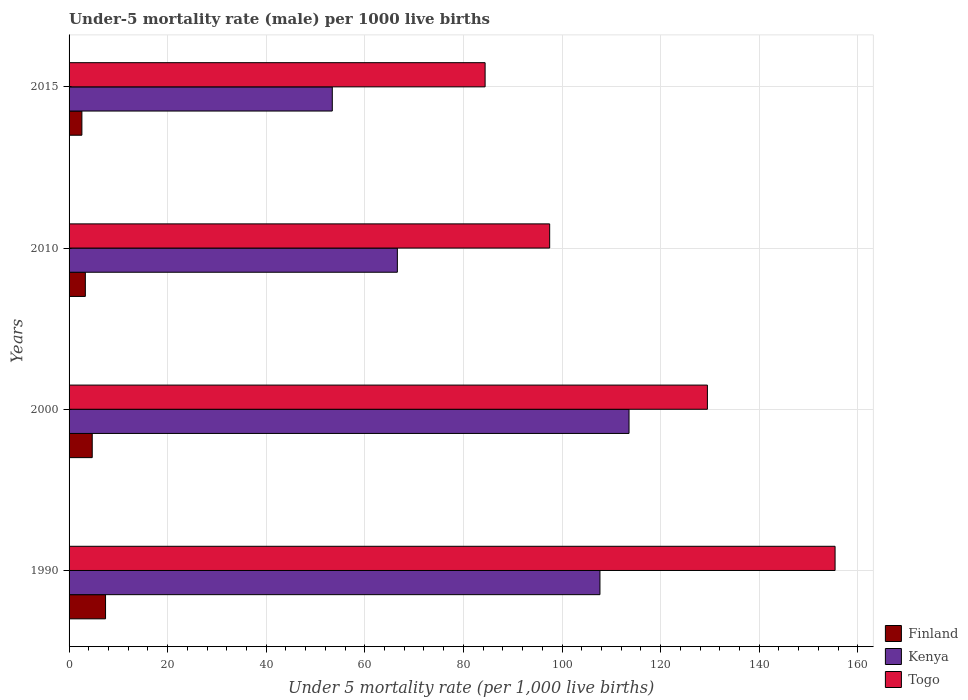How many groups of bars are there?
Ensure brevity in your answer.  4. Are the number of bars per tick equal to the number of legend labels?
Make the answer very short. Yes. Are the number of bars on each tick of the Y-axis equal?
Your answer should be compact. Yes. How many bars are there on the 2nd tick from the bottom?
Provide a succinct answer. 3. Across all years, what is the minimum under-five mortality rate in Finland?
Your answer should be very brief. 2.6. In which year was the under-five mortality rate in Kenya maximum?
Provide a short and direct response. 2000. In which year was the under-five mortality rate in Kenya minimum?
Offer a terse response. 2015. What is the total under-five mortality rate in Togo in the graph?
Your answer should be compact. 466.8. What is the difference between the under-five mortality rate in Kenya in 1990 and that in 2000?
Offer a very short reply. -5.9. What is the difference between the under-five mortality rate in Kenya in 2000 and the under-five mortality rate in Togo in 2015?
Ensure brevity in your answer.  29.2. What is the average under-five mortality rate in Togo per year?
Ensure brevity in your answer.  116.7. In the year 1990, what is the difference between the under-five mortality rate in Finland and under-five mortality rate in Togo?
Make the answer very short. -148. What is the ratio of the under-five mortality rate in Kenya in 1990 to that in 2010?
Offer a very short reply. 1.62. Is the under-five mortality rate in Finland in 1990 less than that in 2000?
Provide a short and direct response. No. What is the difference between the highest and the second highest under-five mortality rate in Kenya?
Offer a terse response. 5.9. What does the 3rd bar from the top in 1990 represents?
Your answer should be compact. Finland. What does the 3rd bar from the bottom in 2010 represents?
Give a very brief answer. Togo. How many bars are there?
Your answer should be compact. 12. Are all the bars in the graph horizontal?
Make the answer very short. Yes. What is the difference between two consecutive major ticks on the X-axis?
Your answer should be compact. 20. Does the graph contain any zero values?
Make the answer very short. No. Does the graph contain grids?
Give a very brief answer. Yes. How many legend labels are there?
Provide a succinct answer. 3. What is the title of the graph?
Provide a short and direct response. Under-5 mortality rate (male) per 1000 live births. What is the label or title of the X-axis?
Your answer should be compact. Under 5 mortality rate (per 1,0 live births). What is the Under 5 mortality rate (per 1,000 live births) in Kenya in 1990?
Give a very brief answer. 107.7. What is the Under 5 mortality rate (per 1,000 live births) in Togo in 1990?
Your response must be concise. 155.4. What is the Under 5 mortality rate (per 1,000 live births) in Finland in 2000?
Your response must be concise. 4.7. What is the Under 5 mortality rate (per 1,000 live births) in Kenya in 2000?
Provide a short and direct response. 113.6. What is the Under 5 mortality rate (per 1,000 live births) in Togo in 2000?
Ensure brevity in your answer.  129.5. What is the Under 5 mortality rate (per 1,000 live births) in Kenya in 2010?
Provide a succinct answer. 66.6. What is the Under 5 mortality rate (per 1,000 live births) in Togo in 2010?
Offer a very short reply. 97.5. What is the Under 5 mortality rate (per 1,000 live births) of Finland in 2015?
Your answer should be compact. 2.6. What is the Under 5 mortality rate (per 1,000 live births) of Kenya in 2015?
Ensure brevity in your answer.  53.4. What is the Under 5 mortality rate (per 1,000 live births) in Togo in 2015?
Your answer should be compact. 84.4. Across all years, what is the maximum Under 5 mortality rate (per 1,000 live births) of Kenya?
Your answer should be very brief. 113.6. Across all years, what is the maximum Under 5 mortality rate (per 1,000 live births) in Togo?
Provide a short and direct response. 155.4. Across all years, what is the minimum Under 5 mortality rate (per 1,000 live births) of Kenya?
Your answer should be very brief. 53.4. Across all years, what is the minimum Under 5 mortality rate (per 1,000 live births) in Togo?
Your response must be concise. 84.4. What is the total Under 5 mortality rate (per 1,000 live births) of Finland in the graph?
Offer a very short reply. 18. What is the total Under 5 mortality rate (per 1,000 live births) in Kenya in the graph?
Provide a succinct answer. 341.3. What is the total Under 5 mortality rate (per 1,000 live births) in Togo in the graph?
Keep it short and to the point. 466.8. What is the difference between the Under 5 mortality rate (per 1,000 live births) in Finland in 1990 and that in 2000?
Make the answer very short. 2.7. What is the difference between the Under 5 mortality rate (per 1,000 live births) in Togo in 1990 and that in 2000?
Provide a succinct answer. 25.9. What is the difference between the Under 5 mortality rate (per 1,000 live births) of Kenya in 1990 and that in 2010?
Provide a short and direct response. 41.1. What is the difference between the Under 5 mortality rate (per 1,000 live births) in Togo in 1990 and that in 2010?
Give a very brief answer. 57.9. What is the difference between the Under 5 mortality rate (per 1,000 live births) of Kenya in 1990 and that in 2015?
Ensure brevity in your answer.  54.3. What is the difference between the Under 5 mortality rate (per 1,000 live births) in Togo in 1990 and that in 2015?
Provide a short and direct response. 71. What is the difference between the Under 5 mortality rate (per 1,000 live births) of Finland in 2000 and that in 2010?
Provide a short and direct response. 1.4. What is the difference between the Under 5 mortality rate (per 1,000 live births) of Kenya in 2000 and that in 2010?
Keep it short and to the point. 47. What is the difference between the Under 5 mortality rate (per 1,000 live births) of Finland in 2000 and that in 2015?
Offer a very short reply. 2.1. What is the difference between the Under 5 mortality rate (per 1,000 live births) of Kenya in 2000 and that in 2015?
Give a very brief answer. 60.2. What is the difference between the Under 5 mortality rate (per 1,000 live births) in Togo in 2000 and that in 2015?
Keep it short and to the point. 45.1. What is the difference between the Under 5 mortality rate (per 1,000 live births) in Finland in 2010 and that in 2015?
Offer a very short reply. 0.7. What is the difference between the Under 5 mortality rate (per 1,000 live births) in Kenya in 2010 and that in 2015?
Ensure brevity in your answer.  13.2. What is the difference between the Under 5 mortality rate (per 1,000 live births) in Togo in 2010 and that in 2015?
Your answer should be compact. 13.1. What is the difference between the Under 5 mortality rate (per 1,000 live births) of Finland in 1990 and the Under 5 mortality rate (per 1,000 live births) of Kenya in 2000?
Make the answer very short. -106.2. What is the difference between the Under 5 mortality rate (per 1,000 live births) in Finland in 1990 and the Under 5 mortality rate (per 1,000 live births) in Togo in 2000?
Your response must be concise. -122.1. What is the difference between the Under 5 mortality rate (per 1,000 live births) in Kenya in 1990 and the Under 5 mortality rate (per 1,000 live births) in Togo in 2000?
Your answer should be very brief. -21.8. What is the difference between the Under 5 mortality rate (per 1,000 live births) in Finland in 1990 and the Under 5 mortality rate (per 1,000 live births) in Kenya in 2010?
Your answer should be compact. -59.2. What is the difference between the Under 5 mortality rate (per 1,000 live births) of Finland in 1990 and the Under 5 mortality rate (per 1,000 live births) of Togo in 2010?
Keep it short and to the point. -90.1. What is the difference between the Under 5 mortality rate (per 1,000 live births) in Finland in 1990 and the Under 5 mortality rate (per 1,000 live births) in Kenya in 2015?
Ensure brevity in your answer.  -46. What is the difference between the Under 5 mortality rate (per 1,000 live births) of Finland in 1990 and the Under 5 mortality rate (per 1,000 live births) of Togo in 2015?
Provide a short and direct response. -77. What is the difference between the Under 5 mortality rate (per 1,000 live births) in Kenya in 1990 and the Under 5 mortality rate (per 1,000 live births) in Togo in 2015?
Keep it short and to the point. 23.3. What is the difference between the Under 5 mortality rate (per 1,000 live births) of Finland in 2000 and the Under 5 mortality rate (per 1,000 live births) of Kenya in 2010?
Your response must be concise. -61.9. What is the difference between the Under 5 mortality rate (per 1,000 live births) in Finland in 2000 and the Under 5 mortality rate (per 1,000 live births) in Togo in 2010?
Your answer should be compact. -92.8. What is the difference between the Under 5 mortality rate (per 1,000 live births) of Kenya in 2000 and the Under 5 mortality rate (per 1,000 live births) of Togo in 2010?
Give a very brief answer. 16.1. What is the difference between the Under 5 mortality rate (per 1,000 live births) in Finland in 2000 and the Under 5 mortality rate (per 1,000 live births) in Kenya in 2015?
Give a very brief answer. -48.7. What is the difference between the Under 5 mortality rate (per 1,000 live births) in Finland in 2000 and the Under 5 mortality rate (per 1,000 live births) in Togo in 2015?
Give a very brief answer. -79.7. What is the difference between the Under 5 mortality rate (per 1,000 live births) of Kenya in 2000 and the Under 5 mortality rate (per 1,000 live births) of Togo in 2015?
Your answer should be compact. 29.2. What is the difference between the Under 5 mortality rate (per 1,000 live births) of Finland in 2010 and the Under 5 mortality rate (per 1,000 live births) of Kenya in 2015?
Give a very brief answer. -50.1. What is the difference between the Under 5 mortality rate (per 1,000 live births) in Finland in 2010 and the Under 5 mortality rate (per 1,000 live births) in Togo in 2015?
Offer a very short reply. -81.1. What is the difference between the Under 5 mortality rate (per 1,000 live births) of Kenya in 2010 and the Under 5 mortality rate (per 1,000 live births) of Togo in 2015?
Your response must be concise. -17.8. What is the average Under 5 mortality rate (per 1,000 live births) in Finland per year?
Offer a terse response. 4.5. What is the average Under 5 mortality rate (per 1,000 live births) in Kenya per year?
Give a very brief answer. 85.33. What is the average Under 5 mortality rate (per 1,000 live births) of Togo per year?
Give a very brief answer. 116.7. In the year 1990, what is the difference between the Under 5 mortality rate (per 1,000 live births) in Finland and Under 5 mortality rate (per 1,000 live births) in Kenya?
Provide a short and direct response. -100.3. In the year 1990, what is the difference between the Under 5 mortality rate (per 1,000 live births) of Finland and Under 5 mortality rate (per 1,000 live births) of Togo?
Offer a terse response. -148. In the year 1990, what is the difference between the Under 5 mortality rate (per 1,000 live births) of Kenya and Under 5 mortality rate (per 1,000 live births) of Togo?
Your answer should be compact. -47.7. In the year 2000, what is the difference between the Under 5 mortality rate (per 1,000 live births) in Finland and Under 5 mortality rate (per 1,000 live births) in Kenya?
Make the answer very short. -108.9. In the year 2000, what is the difference between the Under 5 mortality rate (per 1,000 live births) of Finland and Under 5 mortality rate (per 1,000 live births) of Togo?
Give a very brief answer. -124.8. In the year 2000, what is the difference between the Under 5 mortality rate (per 1,000 live births) of Kenya and Under 5 mortality rate (per 1,000 live births) of Togo?
Provide a short and direct response. -15.9. In the year 2010, what is the difference between the Under 5 mortality rate (per 1,000 live births) of Finland and Under 5 mortality rate (per 1,000 live births) of Kenya?
Make the answer very short. -63.3. In the year 2010, what is the difference between the Under 5 mortality rate (per 1,000 live births) in Finland and Under 5 mortality rate (per 1,000 live births) in Togo?
Your response must be concise. -94.2. In the year 2010, what is the difference between the Under 5 mortality rate (per 1,000 live births) of Kenya and Under 5 mortality rate (per 1,000 live births) of Togo?
Ensure brevity in your answer.  -30.9. In the year 2015, what is the difference between the Under 5 mortality rate (per 1,000 live births) of Finland and Under 5 mortality rate (per 1,000 live births) of Kenya?
Ensure brevity in your answer.  -50.8. In the year 2015, what is the difference between the Under 5 mortality rate (per 1,000 live births) in Finland and Under 5 mortality rate (per 1,000 live births) in Togo?
Keep it short and to the point. -81.8. In the year 2015, what is the difference between the Under 5 mortality rate (per 1,000 live births) of Kenya and Under 5 mortality rate (per 1,000 live births) of Togo?
Offer a very short reply. -31. What is the ratio of the Under 5 mortality rate (per 1,000 live births) of Finland in 1990 to that in 2000?
Offer a very short reply. 1.57. What is the ratio of the Under 5 mortality rate (per 1,000 live births) in Kenya in 1990 to that in 2000?
Give a very brief answer. 0.95. What is the ratio of the Under 5 mortality rate (per 1,000 live births) in Finland in 1990 to that in 2010?
Ensure brevity in your answer.  2.24. What is the ratio of the Under 5 mortality rate (per 1,000 live births) of Kenya in 1990 to that in 2010?
Your answer should be very brief. 1.62. What is the ratio of the Under 5 mortality rate (per 1,000 live births) in Togo in 1990 to that in 2010?
Ensure brevity in your answer.  1.59. What is the ratio of the Under 5 mortality rate (per 1,000 live births) of Finland in 1990 to that in 2015?
Your response must be concise. 2.85. What is the ratio of the Under 5 mortality rate (per 1,000 live births) in Kenya in 1990 to that in 2015?
Make the answer very short. 2.02. What is the ratio of the Under 5 mortality rate (per 1,000 live births) in Togo in 1990 to that in 2015?
Your answer should be compact. 1.84. What is the ratio of the Under 5 mortality rate (per 1,000 live births) in Finland in 2000 to that in 2010?
Give a very brief answer. 1.42. What is the ratio of the Under 5 mortality rate (per 1,000 live births) of Kenya in 2000 to that in 2010?
Offer a terse response. 1.71. What is the ratio of the Under 5 mortality rate (per 1,000 live births) of Togo in 2000 to that in 2010?
Your response must be concise. 1.33. What is the ratio of the Under 5 mortality rate (per 1,000 live births) of Finland in 2000 to that in 2015?
Your response must be concise. 1.81. What is the ratio of the Under 5 mortality rate (per 1,000 live births) in Kenya in 2000 to that in 2015?
Your answer should be compact. 2.13. What is the ratio of the Under 5 mortality rate (per 1,000 live births) of Togo in 2000 to that in 2015?
Provide a short and direct response. 1.53. What is the ratio of the Under 5 mortality rate (per 1,000 live births) in Finland in 2010 to that in 2015?
Ensure brevity in your answer.  1.27. What is the ratio of the Under 5 mortality rate (per 1,000 live births) of Kenya in 2010 to that in 2015?
Ensure brevity in your answer.  1.25. What is the ratio of the Under 5 mortality rate (per 1,000 live births) in Togo in 2010 to that in 2015?
Provide a succinct answer. 1.16. What is the difference between the highest and the second highest Under 5 mortality rate (per 1,000 live births) of Togo?
Provide a succinct answer. 25.9. What is the difference between the highest and the lowest Under 5 mortality rate (per 1,000 live births) in Kenya?
Make the answer very short. 60.2. 